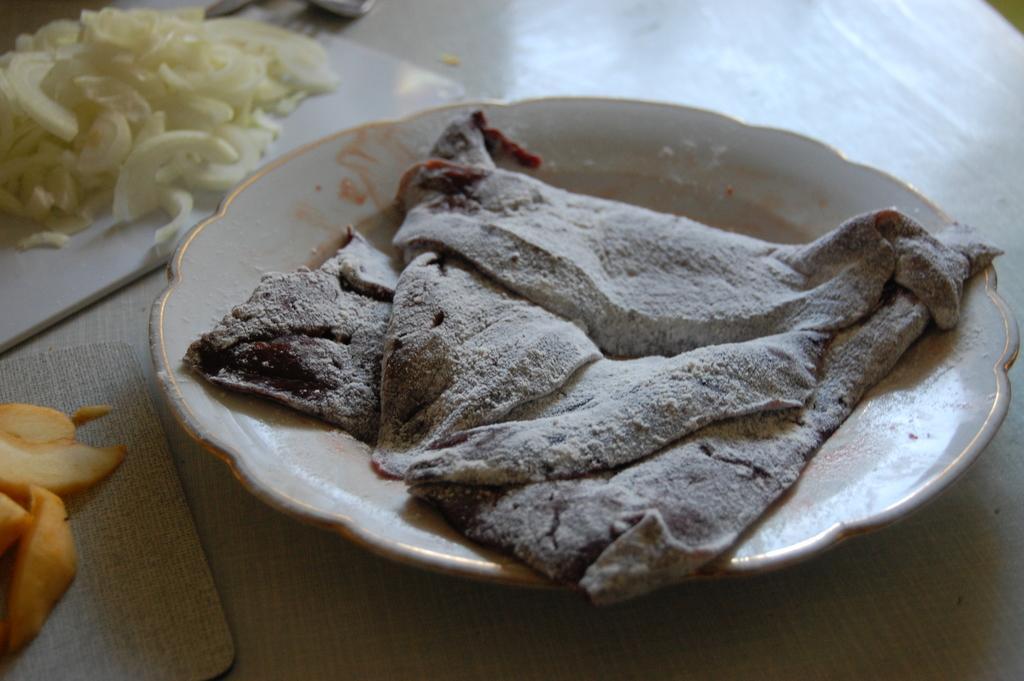Can you describe this image briefly? In this picture I can see there is some food placed on the plate and there is some more food placed on the trays. These are placed on the wooden table. 